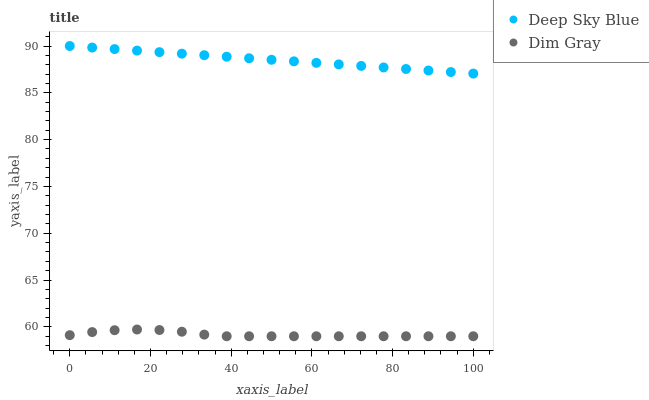Does Dim Gray have the minimum area under the curve?
Answer yes or no. Yes. Does Deep Sky Blue have the maximum area under the curve?
Answer yes or no. Yes. Does Deep Sky Blue have the minimum area under the curve?
Answer yes or no. No. Is Deep Sky Blue the smoothest?
Answer yes or no. Yes. Is Dim Gray the roughest?
Answer yes or no. Yes. Is Deep Sky Blue the roughest?
Answer yes or no. No. Does Dim Gray have the lowest value?
Answer yes or no. Yes. Does Deep Sky Blue have the lowest value?
Answer yes or no. No. Does Deep Sky Blue have the highest value?
Answer yes or no. Yes. Is Dim Gray less than Deep Sky Blue?
Answer yes or no. Yes. Is Deep Sky Blue greater than Dim Gray?
Answer yes or no. Yes. Does Dim Gray intersect Deep Sky Blue?
Answer yes or no. No. 